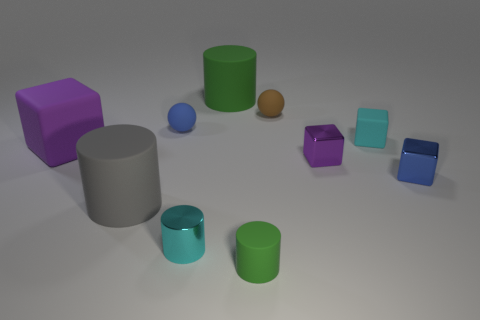There is a green thing behind the small blue matte object; is its shape the same as the small cyan thing that is left of the brown rubber sphere?
Ensure brevity in your answer.  Yes. What shape is the purple thing that is to the right of the small matte object that is in front of the purple rubber thing?
Your answer should be compact. Cube. What size is the block that is the same color as the small metallic cylinder?
Your answer should be compact. Small. Are there any large gray balls made of the same material as the brown thing?
Your answer should be very brief. No. There is a purple object that is right of the small green matte object; what is it made of?
Make the answer very short. Metal. What material is the brown thing?
Provide a short and direct response. Rubber. Is the green thing in front of the blue block made of the same material as the large purple block?
Offer a terse response. Yes. Is the number of blue objects that are right of the tiny cyan cylinder less than the number of large purple rubber objects?
Make the answer very short. No. What color is the rubber cube that is the same size as the blue sphere?
Your answer should be compact. Cyan. How many other small shiny things are the same shape as the purple metal thing?
Ensure brevity in your answer.  1. 